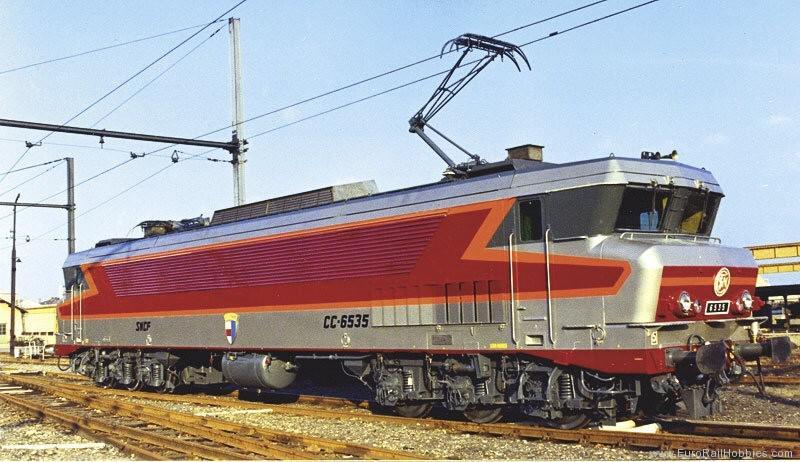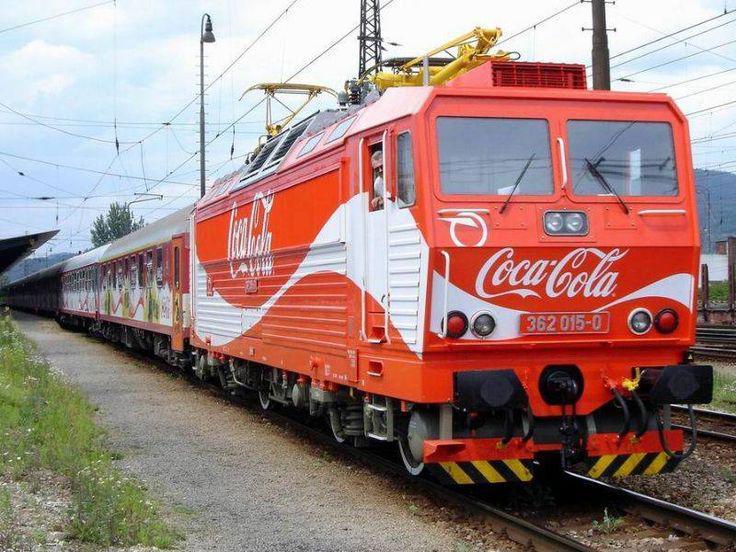The first image is the image on the left, the second image is the image on the right. Assess this claim about the two images: "People wait outside the station to board a red train.". Correct or not? Answer yes or no. No. The first image is the image on the left, the second image is the image on the right. Evaluate the accuracy of this statement regarding the images: "There is absolutely no visible grass in any of the images.". Is it true? Answer yes or no. No. 